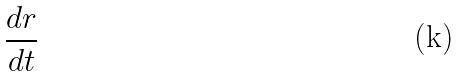<formula> <loc_0><loc_0><loc_500><loc_500>\frac { d r } { d t }</formula> 